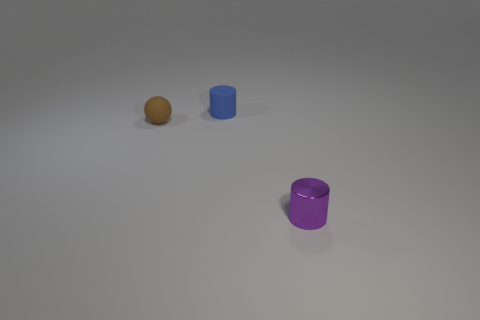There is a cylinder on the left side of the purple metallic object; is it the same size as the thing right of the tiny blue rubber thing?
Make the answer very short. Yes. What number of cylinders are tiny brown rubber things or tiny purple metallic objects?
Your answer should be very brief. 1. What number of shiny things are purple blocks or spheres?
Give a very brief answer. 0. There is another thing that is the same shape as the small blue rubber thing; what size is it?
Ensure brevity in your answer.  Small. Is there anything else that has the same size as the blue matte object?
Give a very brief answer. Yes. Does the purple cylinder have the same size as the thing that is behind the brown ball?
Make the answer very short. Yes. What is the shape of the object to the left of the small blue matte cylinder?
Offer a very short reply. Sphere. What is the color of the matte thing that is left of the small cylinder that is left of the tiny metal object?
Give a very brief answer. Brown. What color is the other small matte object that is the same shape as the tiny purple thing?
Make the answer very short. Blue. Is the color of the tiny matte cylinder the same as the small thing that is in front of the tiny brown matte thing?
Your response must be concise. No. 